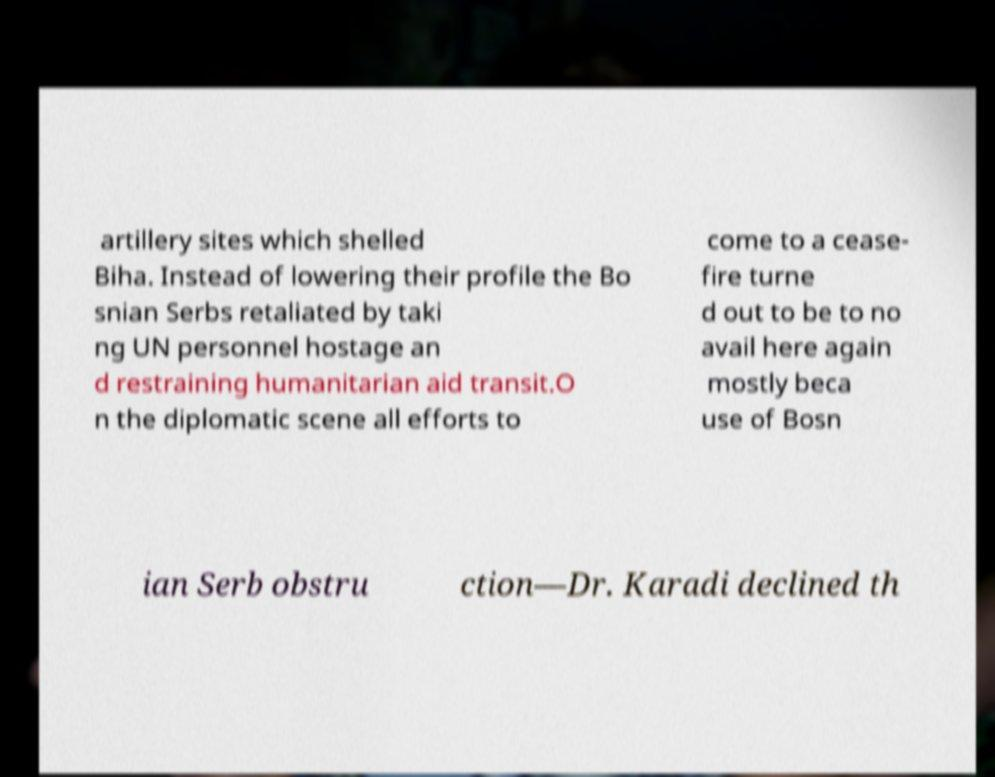Could you assist in decoding the text presented in this image and type it out clearly? artillery sites which shelled Biha. Instead of lowering their profile the Bo snian Serbs retaliated by taki ng UN personnel hostage an d restraining humanitarian aid transit.O n the diplomatic scene all efforts to come to a cease- fire turne d out to be to no avail here again mostly beca use of Bosn ian Serb obstru ction—Dr. Karadi declined th 